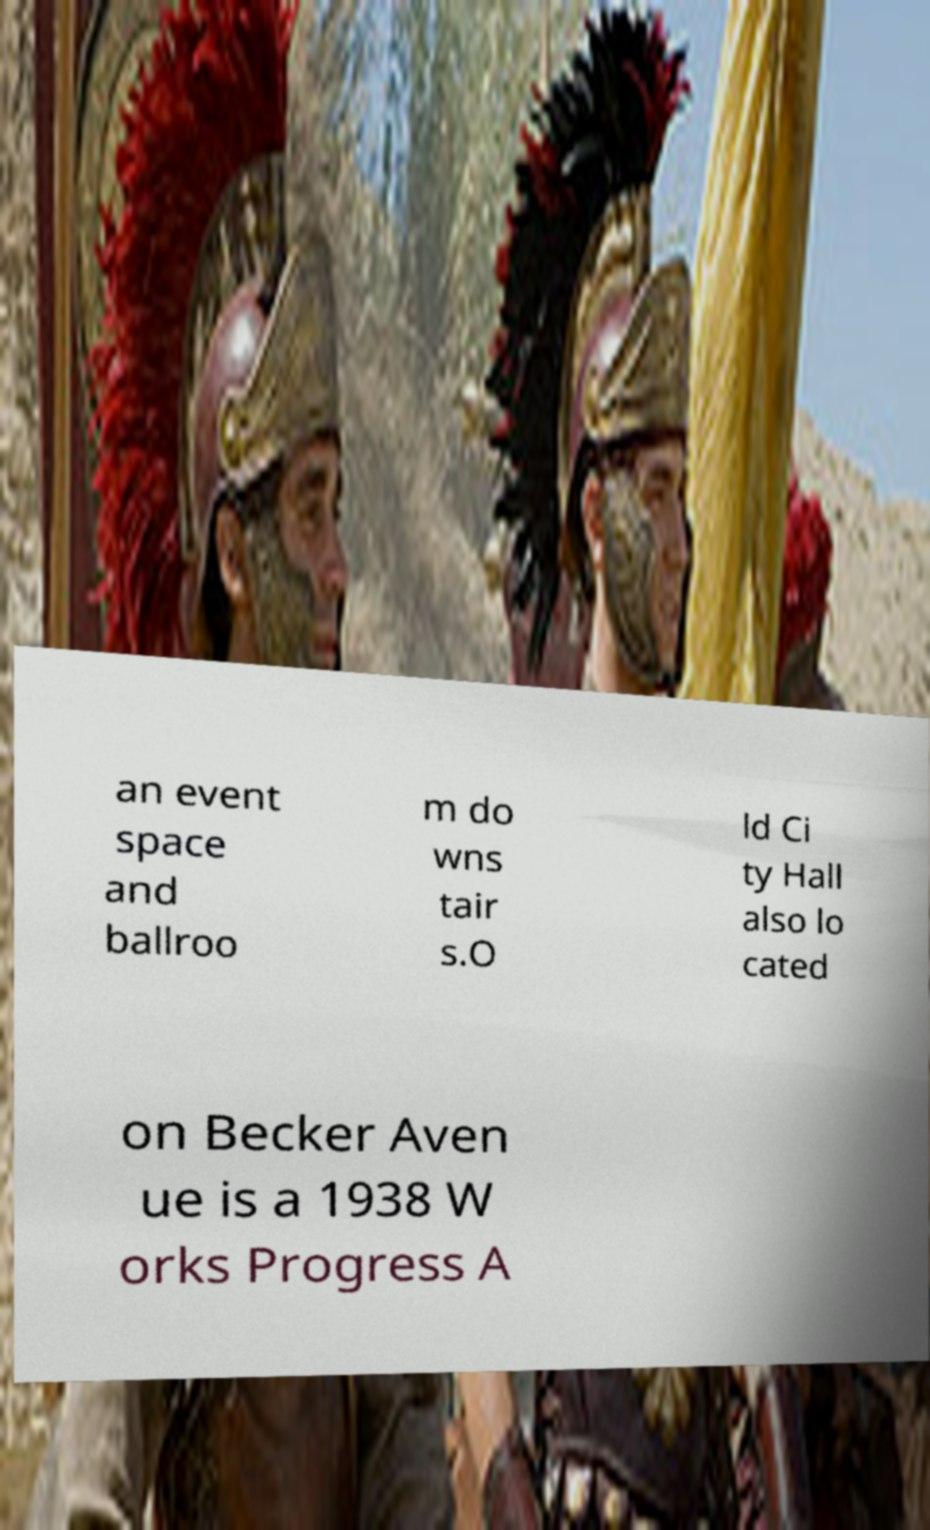For documentation purposes, I need the text within this image transcribed. Could you provide that? an event space and ballroo m do wns tair s.O ld Ci ty Hall also lo cated on Becker Aven ue is a 1938 W orks Progress A 